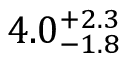<formula> <loc_0><loc_0><loc_500><loc_500>4 . 0 _ { - 1 . 8 } ^ { + 2 . 3 }</formula> 